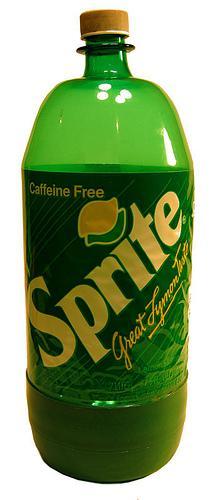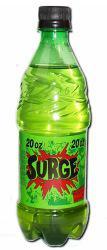The first image is the image on the left, the second image is the image on the right. Evaluate the accuracy of this statement regarding the images: "All of the soda bottles are green.". Is it true? Answer yes or no. Yes. The first image is the image on the left, the second image is the image on the right. Assess this claim about the two images: "There are two bottles total.". Correct or not? Answer yes or no. Yes. 